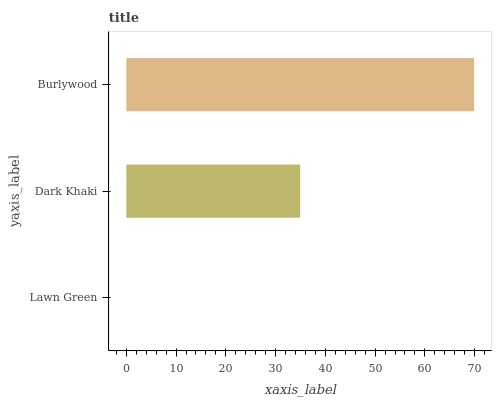Is Lawn Green the minimum?
Answer yes or no. Yes. Is Burlywood the maximum?
Answer yes or no. Yes. Is Dark Khaki the minimum?
Answer yes or no. No. Is Dark Khaki the maximum?
Answer yes or no. No. Is Dark Khaki greater than Lawn Green?
Answer yes or no. Yes. Is Lawn Green less than Dark Khaki?
Answer yes or no. Yes. Is Lawn Green greater than Dark Khaki?
Answer yes or no. No. Is Dark Khaki less than Lawn Green?
Answer yes or no. No. Is Dark Khaki the high median?
Answer yes or no. Yes. Is Dark Khaki the low median?
Answer yes or no. Yes. Is Lawn Green the high median?
Answer yes or no. No. Is Lawn Green the low median?
Answer yes or no. No. 